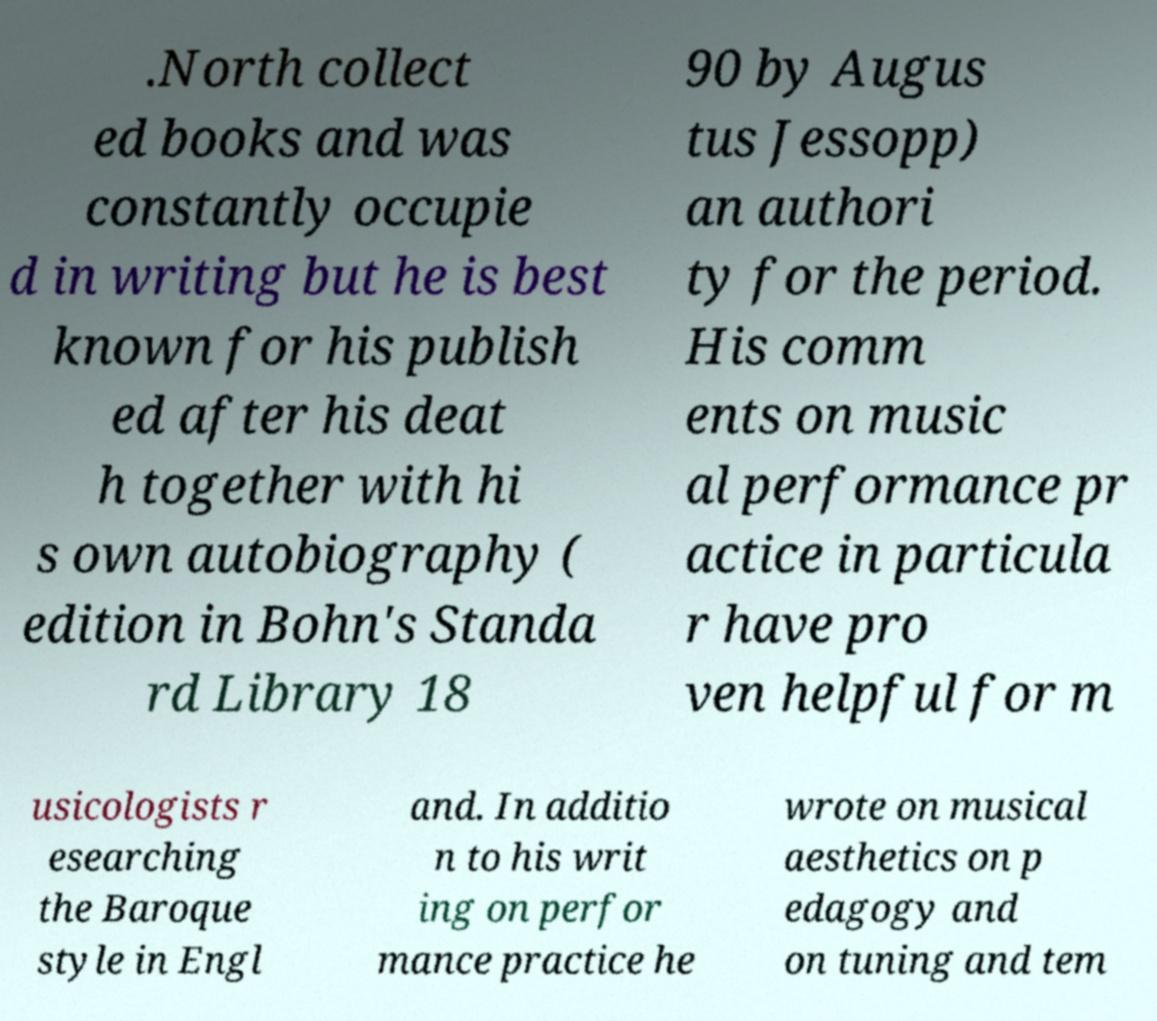Can you accurately transcribe the text from the provided image for me? .North collect ed books and was constantly occupie d in writing but he is best known for his publish ed after his deat h together with hi s own autobiography ( edition in Bohn's Standa rd Library 18 90 by Augus tus Jessopp) an authori ty for the period. His comm ents on music al performance pr actice in particula r have pro ven helpful for m usicologists r esearching the Baroque style in Engl and. In additio n to his writ ing on perfor mance practice he wrote on musical aesthetics on p edagogy and on tuning and tem 